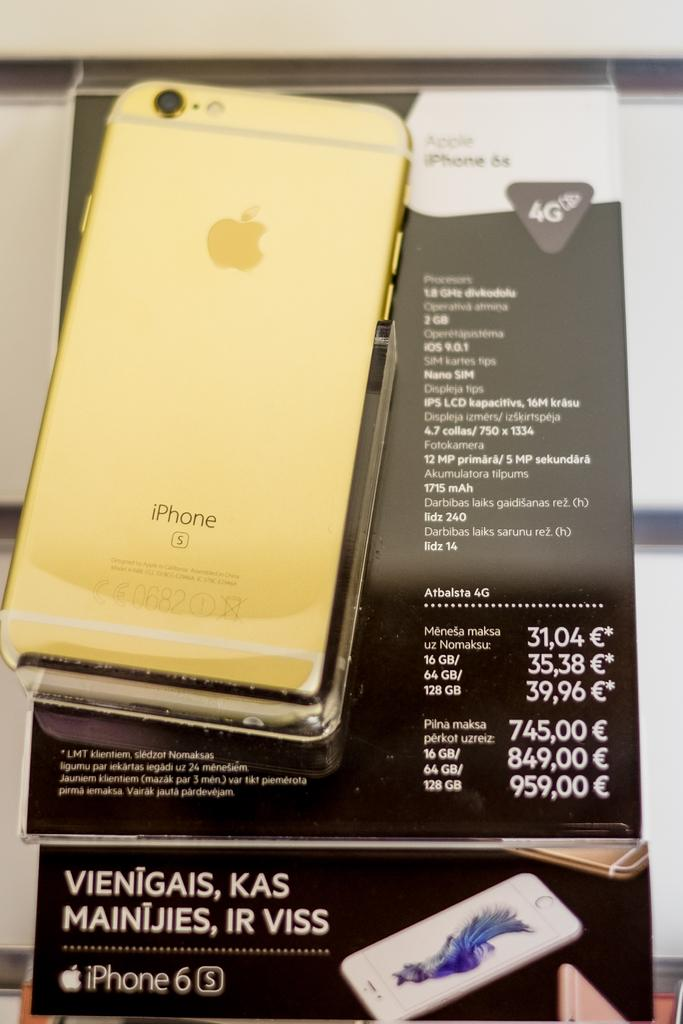<image>
Summarize the visual content of the image. Gold Apple iPhone 6s 4G laid face down. 